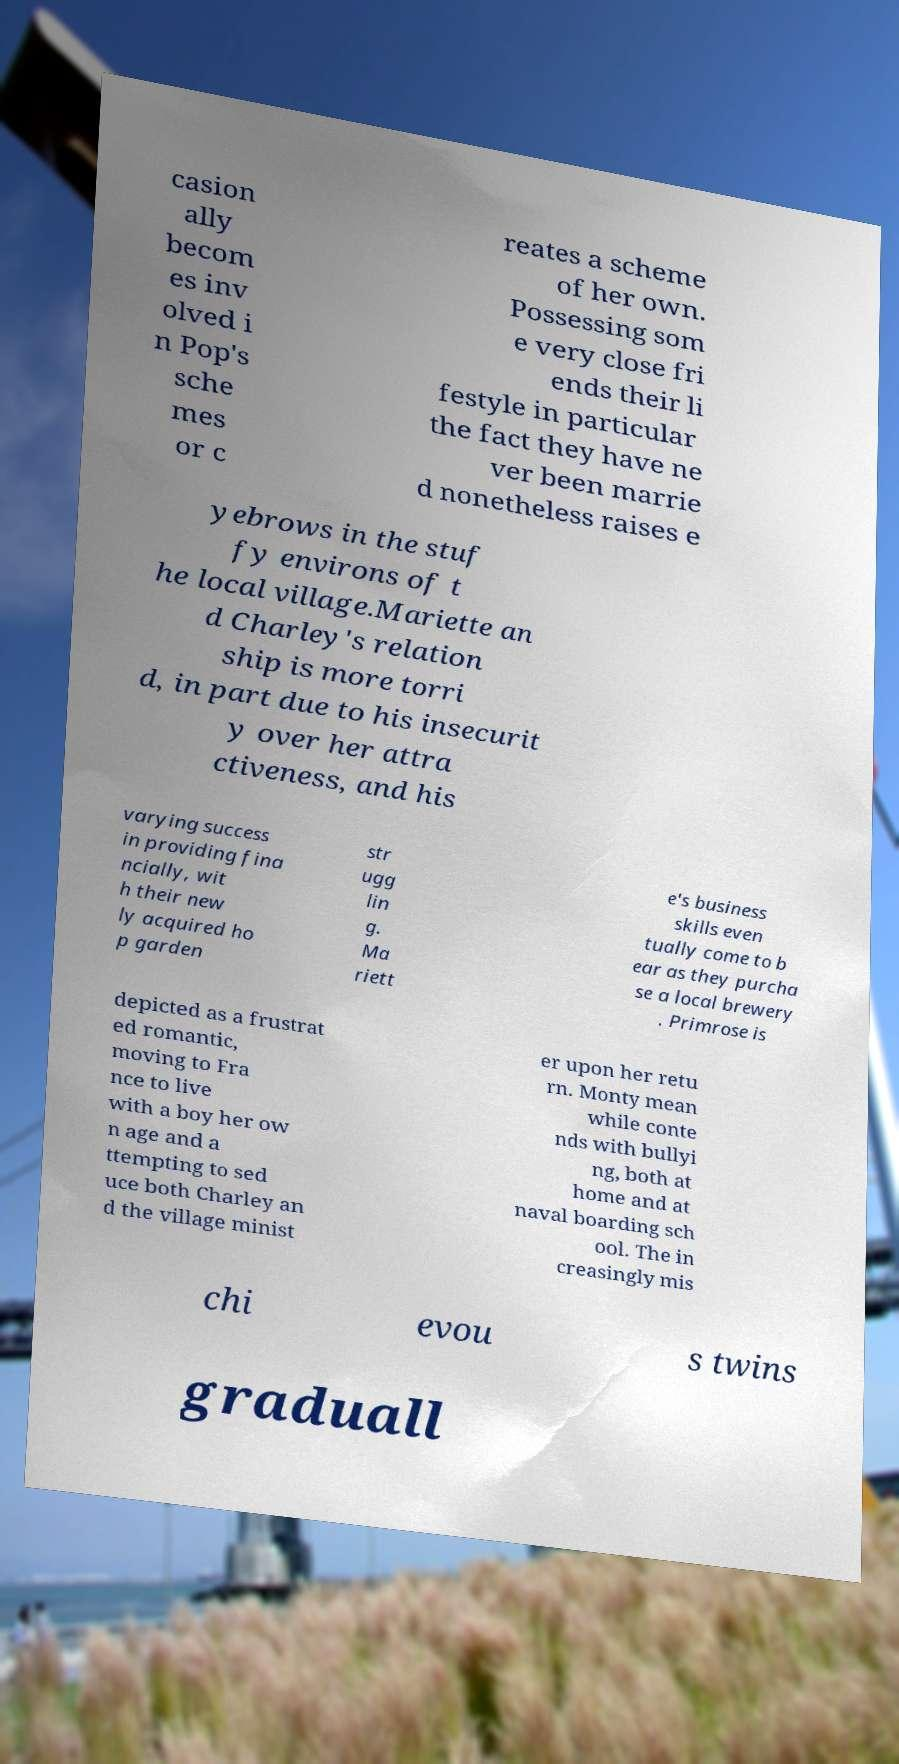Can you read and provide the text displayed in the image?This photo seems to have some interesting text. Can you extract and type it out for me? casion ally becom es inv olved i n Pop's sche mes or c reates a scheme of her own. Possessing som e very close fri ends their li festyle in particular the fact they have ne ver been marrie d nonetheless raises e yebrows in the stuf fy environs of t he local village.Mariette an d Charley's relation ship is more torri d, in part due to his insecurit y over her attra ctiveness, and his varying success in providing fina ncially, wit h their new ly acquired ho p garden str ugg lin g. Ma riett e's business skills even tually come to b ear as they purcha se a local brewery . Primrose is depicted as a frustrat ed romantic, moving to Fra nce to live with a boy her ow n age and a ttempting to sed uce both Charley an d the village minist er upon her retu rn. Monty mean while conte nds with bullyi ng, both at home and at naval boarding sch ool. The in creasingly mis chi evou s twins graduall 